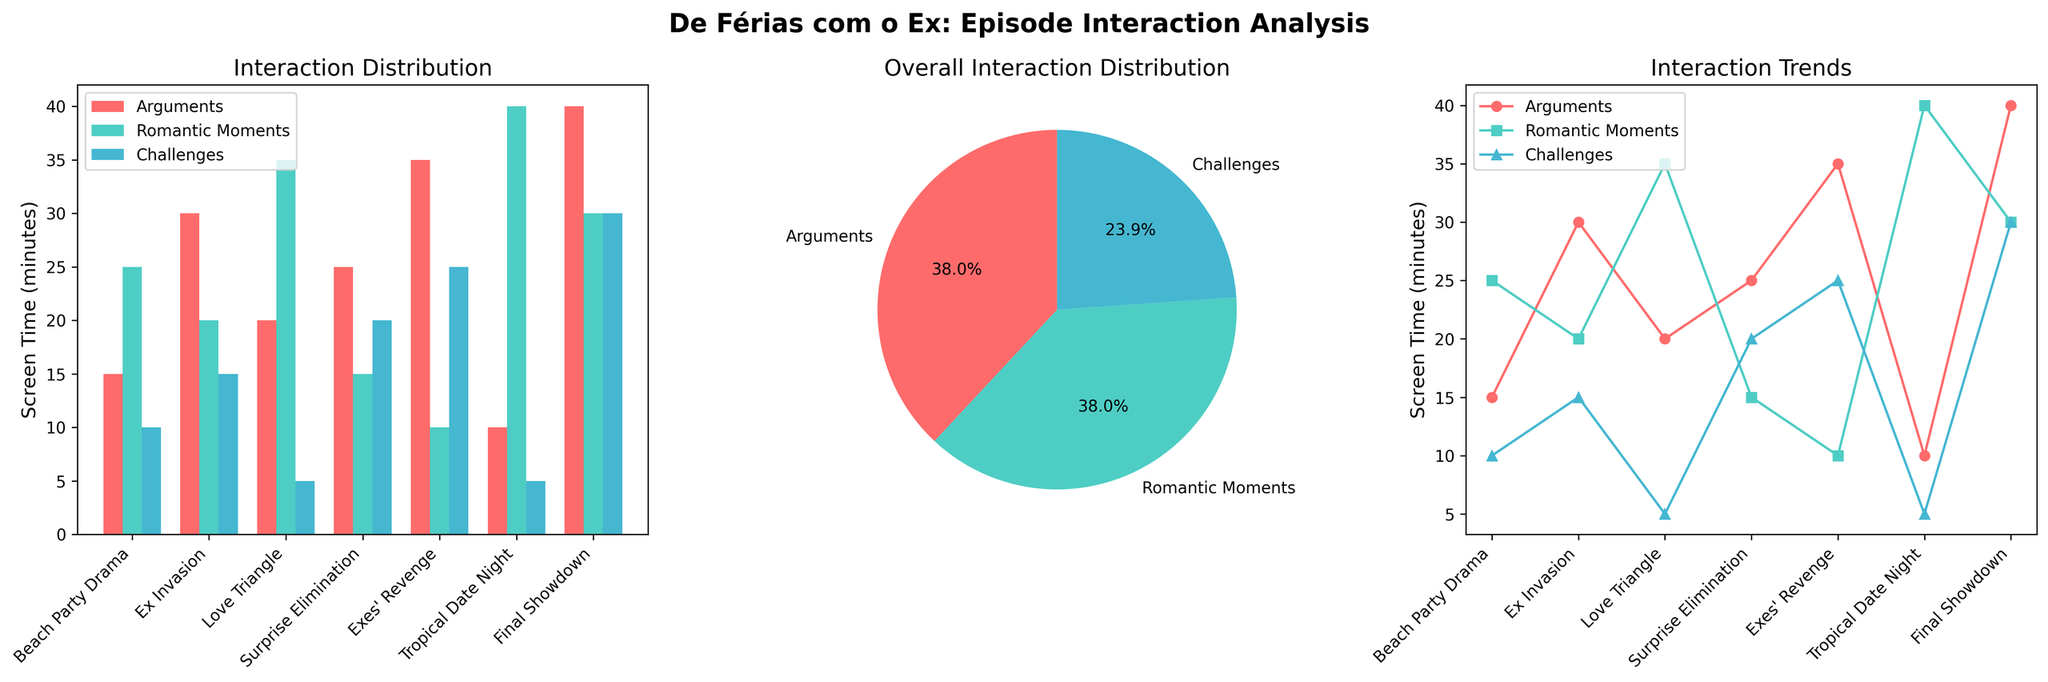What's the title of the bar chart? The bar chart’s title is written above the subplot of the bar chart.
Answer: Interaction Distribution Which episode had the most screen time for arguments? To determine this, look at the bars representing "Arguments" in the bar chart, which are red. The tallest red bar corresponds to "Final Showdown."
Answer: Final Showdown What percentage of the overall interactions were romantic moments? To find this, look at the pie chart. The segment representing "Romantic Moments" is labeled with the percentage.
Answer: 29.2% Which two episodes had the same amount of screen time for challenges? On the bar chart, look for the blue bars representing "Challenges" where the heights are the same. Both "Love Triangle" and "Tropical Date Night" have equal screen time for challenges (5 minutes).
Answer: Love Triangle and Tropical Date Night What is the difference in screen time between arguments and romantic moments in "Ex Invasion"? Refer to the bar chart to see the screen times for "Arguments" (30 minutes) and "Romantic Moments" (20 minutes) in the "Ex Invasion" episode. The difference is 30 - 20.
Answer: 10 minutes Which type of interaction had the least overall screen time? Look at the pie chart for the smallest segment. The smallest segment corresponds to “Challenges.”
Answer: Challenges How many minutes of screen time did challenges have in total across all episodes? Refer to the pie chart for total screen time percentages: 22.2%. But the total numerical value can also be found by summing up challenge times across all episodes (10 + 15 + 5 + 20 + 25 + 5 + 30).
Answer: 110 minutes Which episode saw the steepest increase in argument screen time compared to the previous episode in the line chart? In the line chart, compare the slopes of the line representing "Arguments" between consecutive episodes. The steepest increase is between "Surprise Elimination" (25 minutes) and "Exes' Revenge" (35 minutes), which is an increase of 10 minutes.
Answer: Exes' Revenge Which type of interaction shows the most consistent trend across all episodes? Examine the line chart and compare the variability in the lines representing each interaction type. "Challenges" show the most variability, while "Romantic Moments" fluctuate a lot more, and "Arguments" have varied trends. "Romantic Moments" show less variability than arguments.
Answer: Arguments What is the average screen time for romantic moments across all episodes? Sum the screen time for "Romantic Moments" for all episodes (25 + 20 + 35 + 15 + 10 + 40 + 30) and divide by the number of episodes (7).
Answer: 25 minutes 